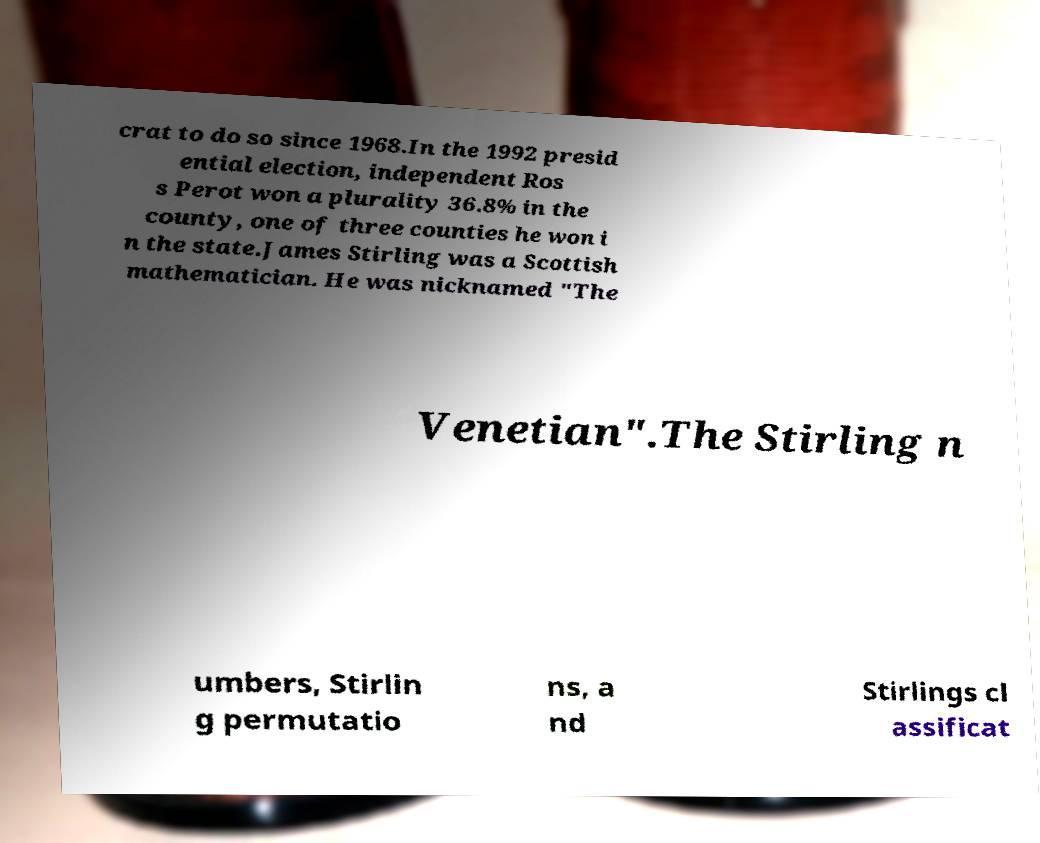There's text embedded in this image that I need extracted. Can you transcribe it verbatim? crat to do so since 1968.In the 1992 presid ential election, independent Ros s Perot won a plurality 36.8% in the county, one of three counties he won i n the state.James Stirling was a Scottish mathematician. He was nicknamed "The Venetian".The Stirling n umbers, Stirlin g permutatio ns, a nd Stirlings cl assificat 